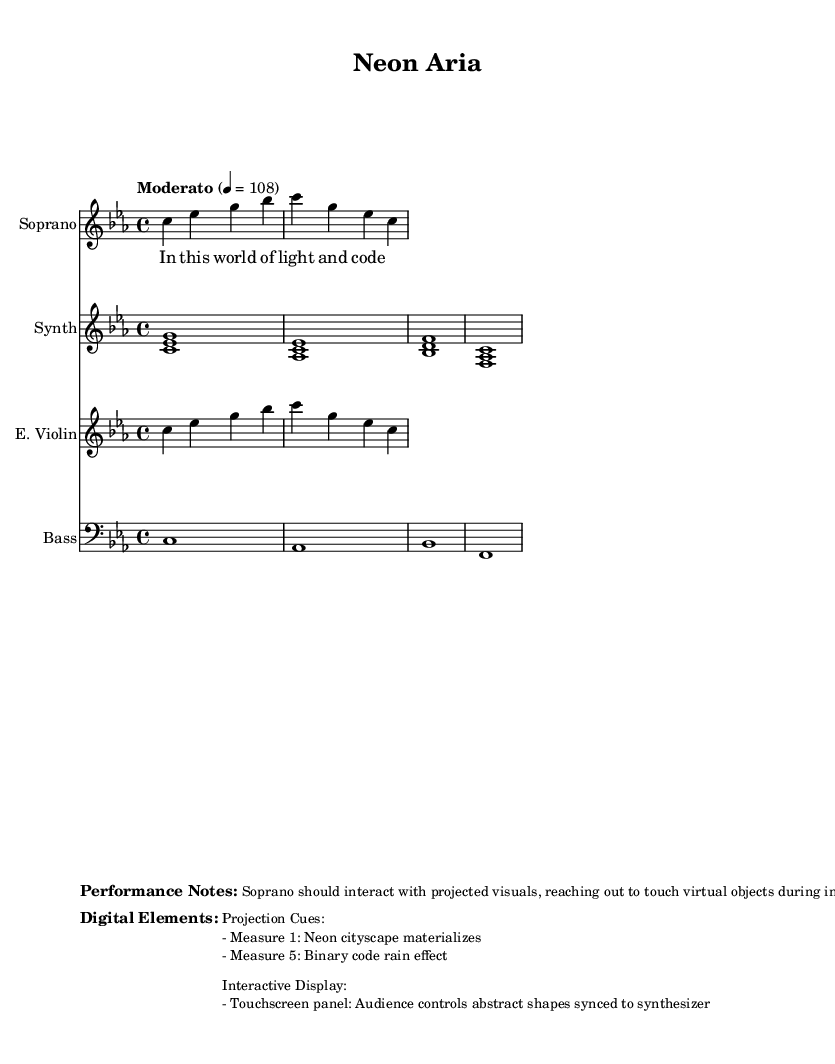What is the key signature of this music? The key signature is indicated in the global section as C minor, which has three flats: B flat, E flat, and A flat.
Answer: C minor What is the time signature of this piece? The time signature is found in the global section as 4/4, which means there are four beats in each measure and a quarter note gets one beat.
Answer: 4/4 What is the tempo marking for the piece? The tempo is specified in the global section as "Moderato" with a metronome marking of 108, meaning a moderate speed of 108 beats per minute.
Answer: Moderato, 108 What instrument is indicated for the synthesizer part? The instrument name is stated in the score as "Synth," which directly identifies the intended instrument for this staff line.
Answer: Synth What visual element appears in Measure 1? According to the performance notes under digital elements, a neon cityscape is mentioned to appear in Measure 1, enhancing the visual presentation of the piece.
Answer: Neon cityscape How does the audience interact with the performance? The digital elements describe a touchscreen panel that allows the audience to control abstract shapes synced with the synthesizer, indicating a level of interactivity during the performance.
Answer: Touchscreen panel What should the soprano do during instrumental breaks? The performance notes specify that the soprano is instructed to interact with projected visuals, which implies an active engagement with the digital content during these sections.
Answer: Interact with projected visuals 